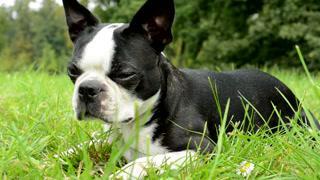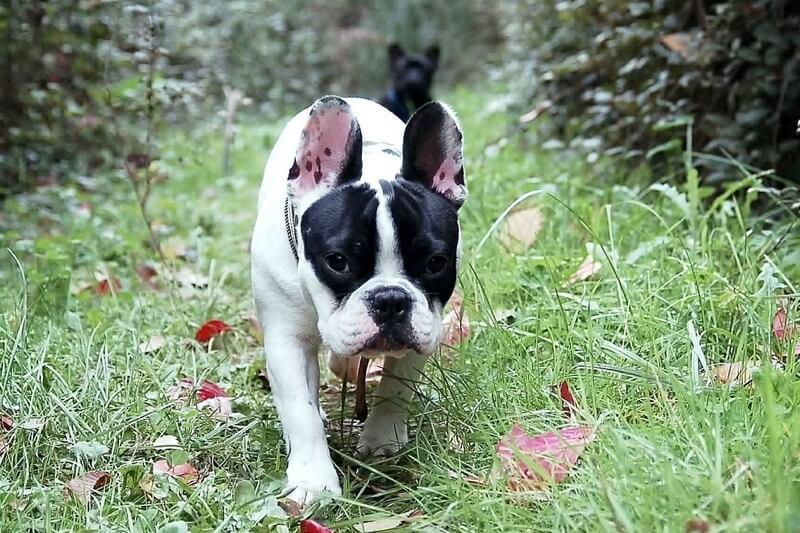The first image is the image on the left, the second image is the image on the right. Assess this claim about the two images: "One of the images shows a bulldog on a leash with its body facing leftward.". Correct or not? Answer yes or no. No. 